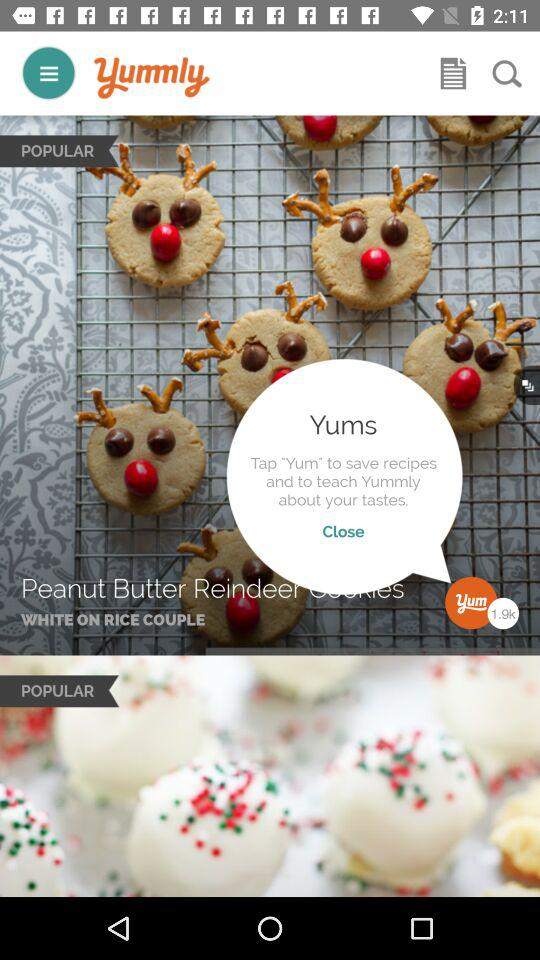What is the app name? The app name is "Yummly". 